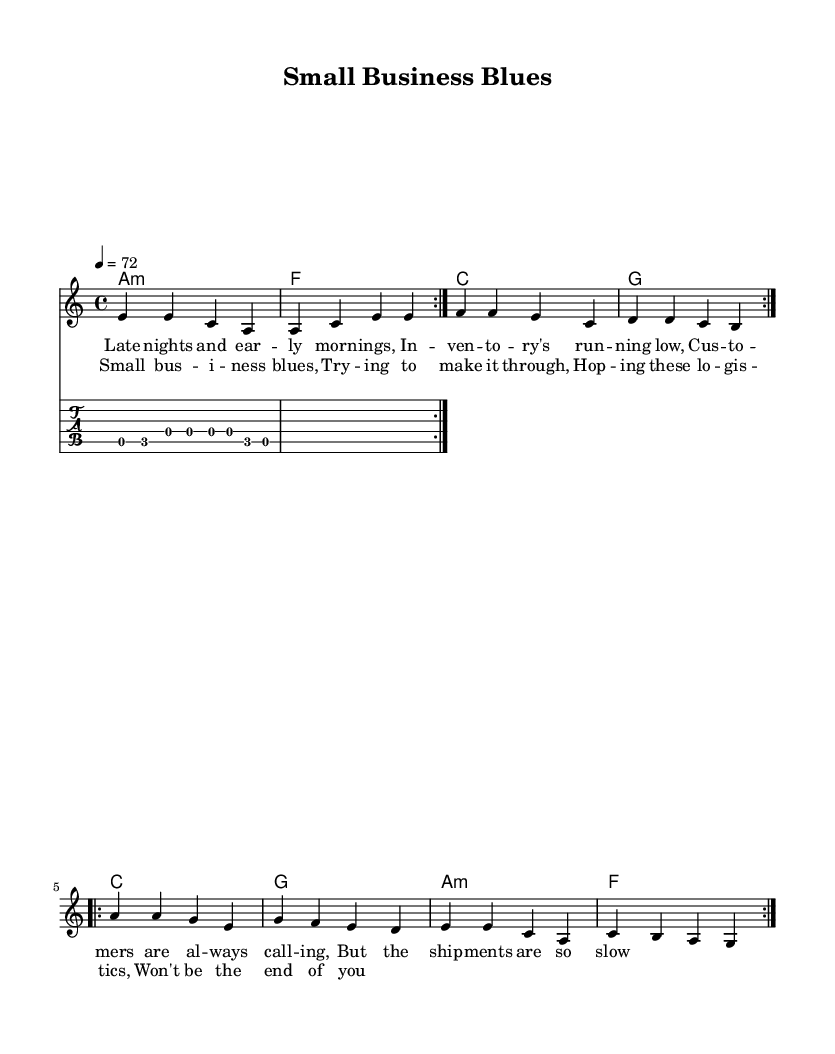What is the key signature of this music? The key signature is A minor, which is indicated by the absence of any sharps or flats in the music sheet.
Answer: A minor What is the time signature of the piece? The time signature is 4/4, which indicates that there are four beats per measure, and the quarter note gets one beat. This is revealed in the initial setup of the music notation.
Answer: 4/4 What is the tempo marking for this music? The tempo marking is 72 beats per minute, as indicated at the beginning of the score with "4 = 72", which refers to the quarter note pulse.
Answer: 72 What is the first lyric line of the verse? The first lyric line of the verse section is "Late nights and ear -- ly morn -- ings," which is located directly above the melody notes in the vocal part.
Answer: Late nights and ear -- ly morn -- ings How many times is the melody repeated in the verses? The melody is repeated two times in the verses, as indicated by the "repeat volta 2" markings in the notation for both the melody and the harmonies.
Answer: 2 What type of harmony is used in the chorus? The harmony used in the chorus consists of a combination of major and minor chords, specifically C major, G major, A minor, and F major as defined in the chord progression.
Answer: Major and minor What is the title of this piece? The title of the piece is "Small Business Blues," which is mentioned in the header section of the score.
Answer: Small Business Blues 